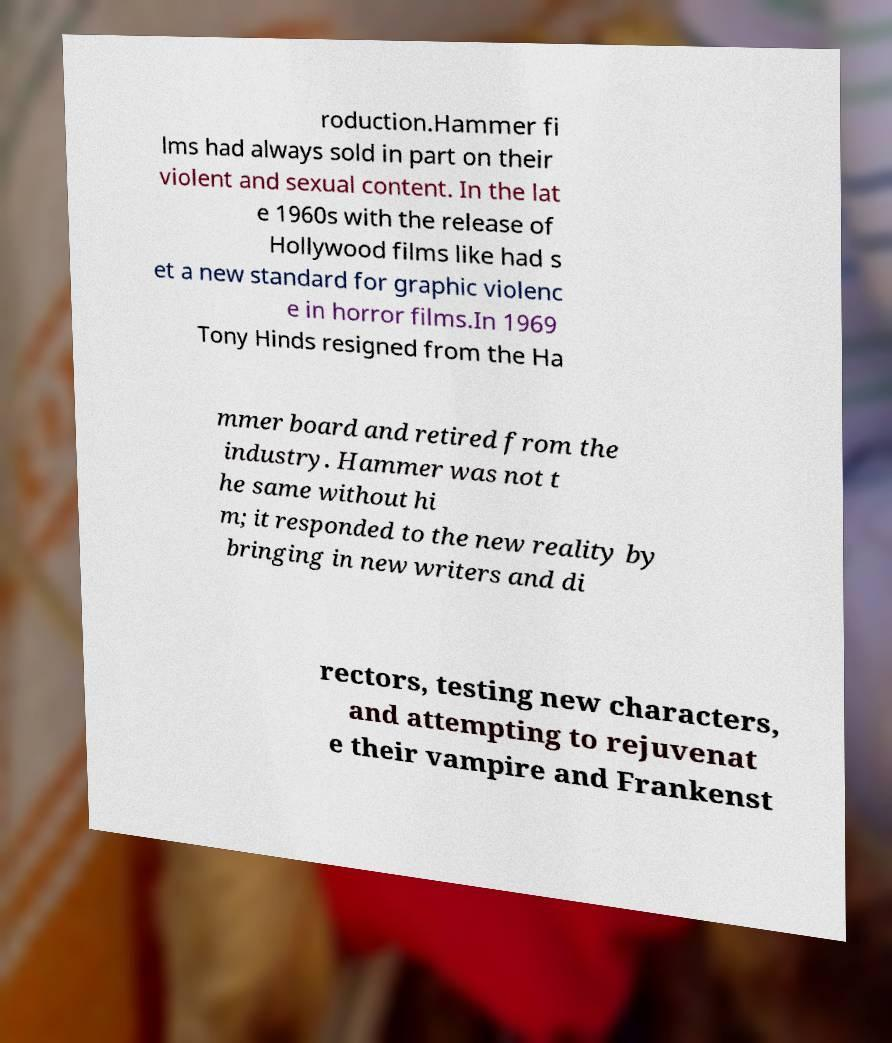There's text embedded in this image that I need extracted. Can you transcribe it verbatim? roduction.Hammer fi lms had always sold in part on their violent and sexual content. In the lat e 1960s with the release of Hollywood films like had s et a new standard for graphic violenc e in horror films.In 1969 Tony Hinds resigned from the Ha mmer board and retired from the industry. Hammer was not t he same without hi m; it responded to the new reality by bringing in new writers and di rectors, testing new characters, and attempting to rejuvenat e their vampire and Frankenst 